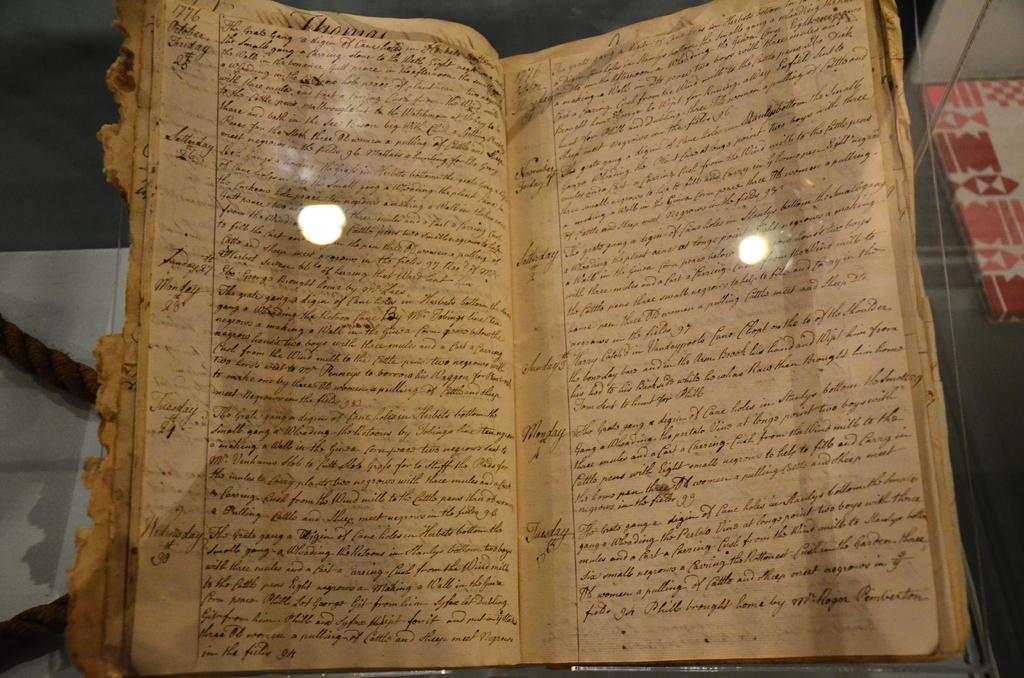<image>
Present a compact description of the photo's key features. An old and ragged book is opened to pages starting with entries made Friday October the 28th. 